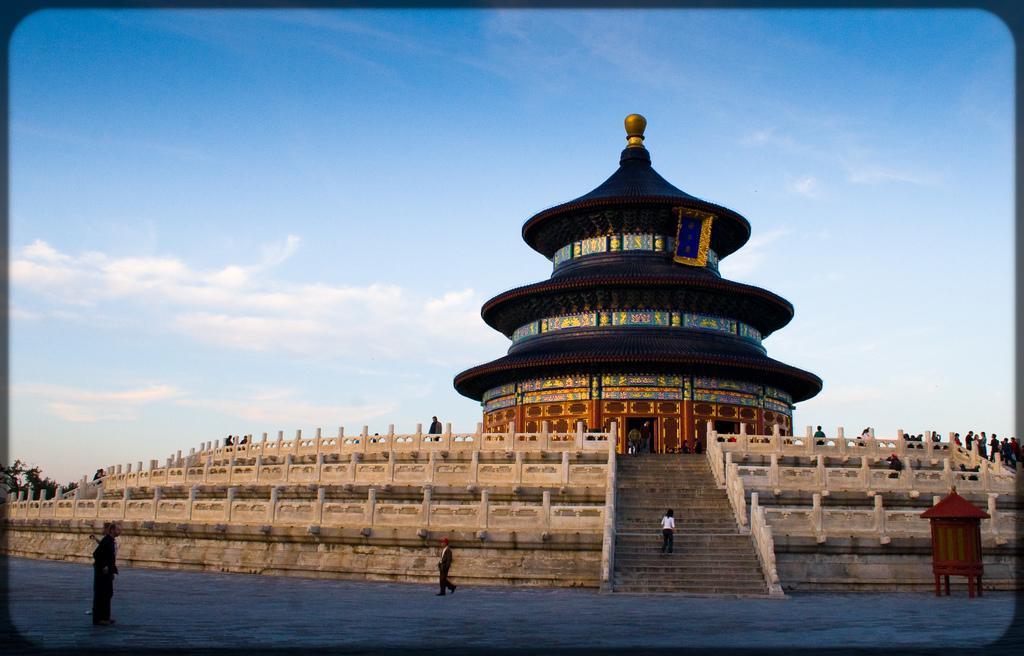Describe this image in one or two sentences. In the picture we can see a historical construction of a temple and besides to it, we can see some steps and railings on the steps and on the path we can see some persons are standing and walking and in the background we can see a sky with clouds. 